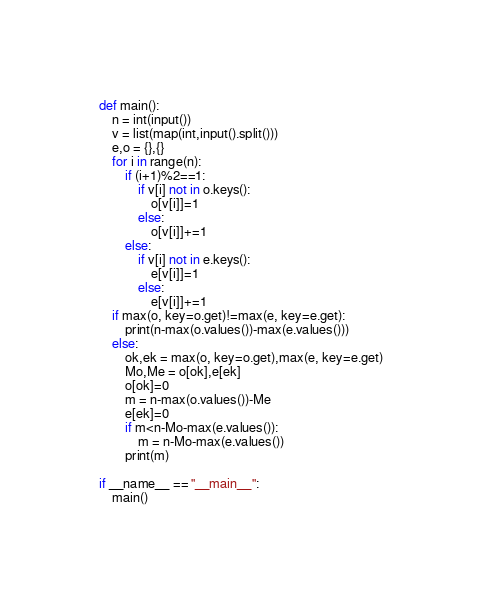<code> <loc_0><loc_0><loc_500><loc_500><_Python_>def main():
    n = int(input())
    v = list(map(int,input().split()))
    e,o = {},{}
    for i in range(n):
        if (i+1)%2==1:
            if v[i] not in o.keys():
                o[v[i]]=1
            else:
                o[v[i]]+=1
        else:
            if v[i] not in e.keys():
                e[v[i]]=1
            else:
                e[v[i]]+=1
    if max(o, key=o.get)!=max(e, key=e.get):
        print(n-max(o.values())-max(e.values()))
    else:
        ok,ek = max(o, key=o.get),max(e, key=e.get)
        Mo,Me = o[ok],e[ek]
        o[ok]=0
        m = n-max(o.values())-Me
        e[ek]=0
        if m<n-Mo-max(e.values()):
            m = n-Mo-max(e.values())
        print(m)

if __name__ == "__main__":
    main()
</code> 